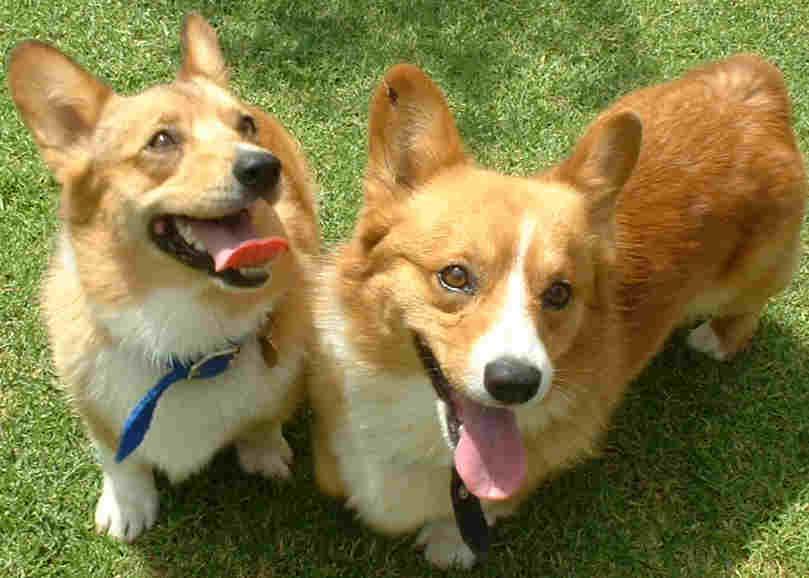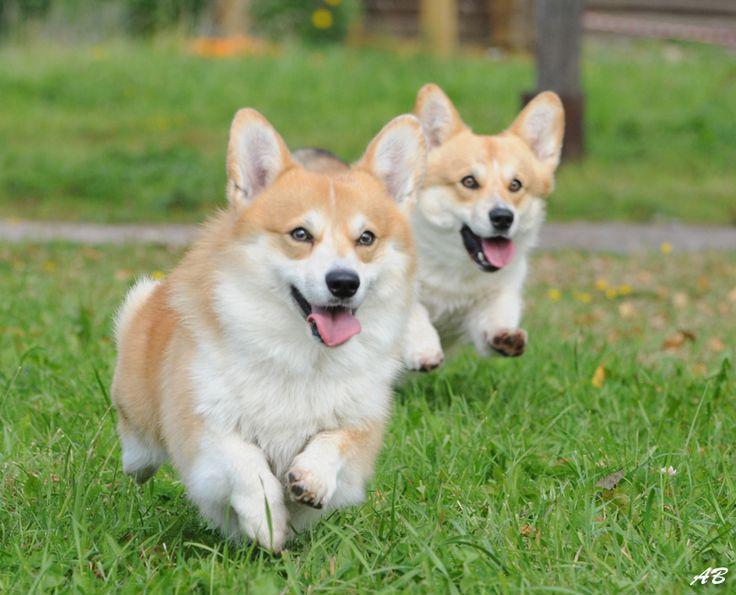The first image is the image on the left, the second image is the image on the right. Given the left and right images, does the statement "Both images in the pair include two corgis next to each other." hold true? Answer yes or no. Yes. The first image is the image on the left, the second image is the image on the right. Given the left and right images, does the statement "There are two puppies with ears pointing up as they run right together on grass." hold true? Answer yes or no. Yes. 